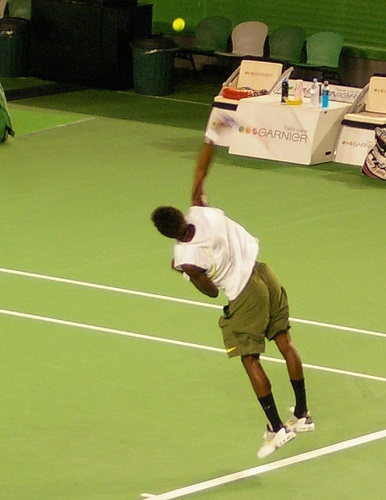Describe the objects in this image and their specific colors. I can see people in gray, olive, beige, and black tones, chair in gray, black, and darkgreen tones, chair in gray, black, tan, and olive tones, tennis racket in gray and tan tones, and chair in gray, darkgreen, and green tones in this image. 